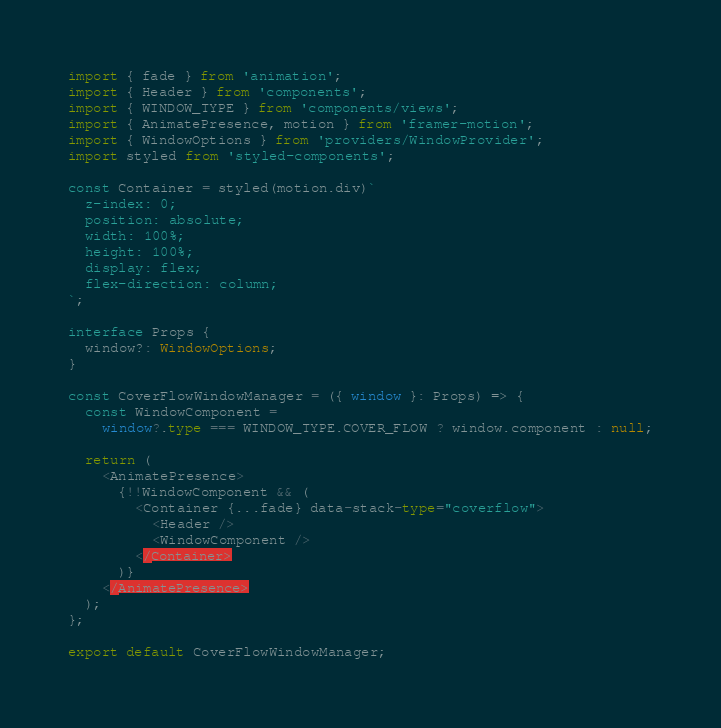<code> <loc_0><loc_0><loc_500><loc_500><_TypeScript_>import { fade } from 'animation';
import { Header } from 'components';
import { WINDOW_TYPE } from 'components/views';
import { AnimatePresence, motion } from 'framer-motion';
import { WindowOptions } from 'providers/WindowProvider';
import styled from 'styled-components';

const Container = styled(motion.div)`
  z-index: 0;
  position: absolute;
  width: 100%;
  height: 100%;
  display: flex;
  flex-direction: column;
`;

interface Props {
  window?: WindowOptions;
}

const CoverFlowWindowManager = ({ window }: Props) => {
  const WindowComponent =
    window?.type === WINDOW_TYPE.COVER_FLOW ? window.component : null;

  return (
    <AnimatePresence>
      {!!WindowComponent && (
        <Container {...fade} data-stack-type="coverflow">
          <Header />
          <WindowComponent />
        </Container>
      )}
    </AnimatePresence>
  );
};

export default CoverFlowWindowManager;
</code> 